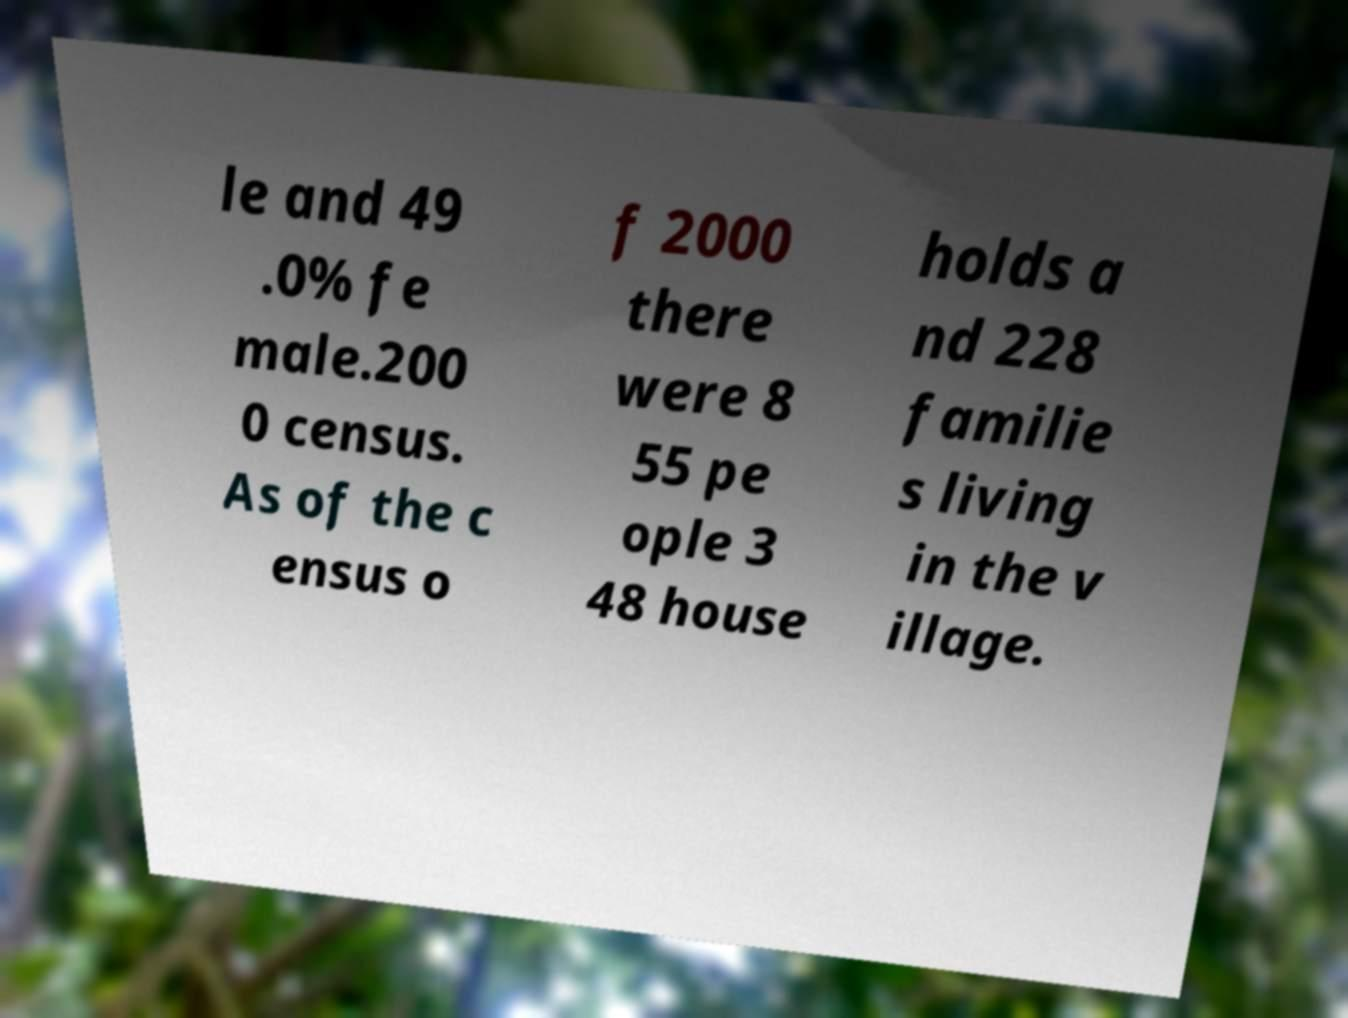Could you extract and type out the text from this image? le and 49 .0% fe male.200 0 census. As of the c ensus o f 2000 there were 8 55 pe ople 3 48 house holds a nd 228 familie s living in the v illage. 